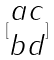Convert formula to latex. <formula><loc_0><loc_0><loc_500><loc_500>[ \begin{matrix} a c \\ b d \end{matrix} ]</formula> 